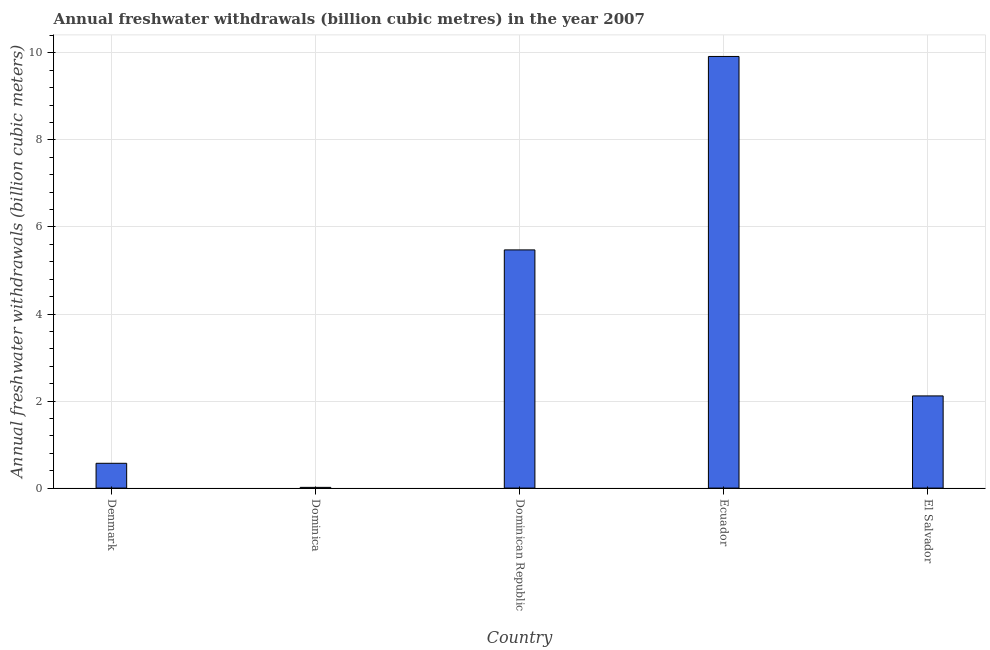Does the graph contain any zero values?
Provide a short and direct response. No. Does the graph contain grids?
Your answer should be compact. Yes. What is the title of the graph?
Give a very brief answer. Annual freshwater withdrawals (billion cubic metres) in the year 2007. What is the label or title of the Y-axis?
Offer a terse response. Annual freshwater withdrawals (billion cubic meters). What is the annual freshwater withdrawals in Denmark?
Your answer should be very brief. 0.57. Across all countries, what is the maximum annual freshwater withdrawals?
Your response must be concise. 9.92. Across all countries, what is the minimum annual freshwater withdrawals?
Make the answer very short. 0.02. In which country was the annual freshwater withdrawals maximum?
Offer a very short reply. Ecuador. In which country was the annual freshwater withdrawals minimum?
Provide a succinct answer. Dominica. What is the sum of the annual freshwater withdrawals?
Make the answer very short. 18.1. What is the difference between the annual freshwater withdrawals in Dominican Republic and Ecuador?
Make the answer very short. -4.45. What is the average annual freshwater withdrawals per country?
Keep it short and to the point. 3.62. What is the median annual freshwater withdrawals?
Offer a terse response. 2.12. What is the ratio of the annual freshwater withdrawals in Dominica to that in El Salvador?
Your answer should be very brief. 0.01. What is the difference between the highest and the second highest annual freshwater withdrawals?
Provide a short and direct response. 4.45. Is the sum of the annual freshwater withdrawals in Dominica and El Salvador greater than the maximum annual freshwater withdrawals across all countries?
Give a very brief answer. No. What is the difference between the highest and the lowest annual freshwater withdrawals?
Keep it short and to the point. 9.9. Are all the bars in the graph horizontal?
Your answer should be very brief. No. How many countries are there in the graph?
Your answer should be very brief. 5. Are the values on the major ticks of Y-axis written in scientific E-notation?
Keep it short and to the point. No. What is the Annual freshwater withdrawals (billion cubic meters) in Denmark?
Ensure brevity in your answer.  0.57. What is the Annual freshwater withdrawals (billion cubic meters) in Dominica?
Provide a succinct answer. 0.02. What is the Annual freshwater withdrawals (billion cubic meters) of Dominican Republic?
Provide a short and direct response. 5.47. What is the Annual freshwater withdrawals (billion cubic meters) of Ecuador?
Offer a very short reply. 9.92. What is the Annual freshwater withdrawals (billion cubic meters) of El Salvador?
Your response must be concise. 2.12. What is the difference between the Annual freshwater withdrawals (billion cubic meters) in Denmark and Dominica?
Your response must be concise. 0.55. What is the difference between the Annual freshwater withdrawals (billion cubic meters) in Denmark and Dominican Republic?
Offer a terse response. -4.9. What is the difference between the Annual freshwater withdrawals (billion cubic meters) in Denmark and Ecuador?
Your response must be concise. -9.35. What is the difference between the Annual freshwater withdrawals (billion cubic meters) in Denmark and El Salvador?
Provide a succinct answer. -1.55. What is the difference between the Annual freshwater withdrawals (billion cubic meters) in Dominica and Dominican Republic?
Your response must be concise. -5.46. What is the difference between the Annual freshwater withdrawals (billion cubic meters) in Dominica and Ecuador?
Your answer should be compact. -9.9. What is the difference between the Annual freshwater withdrawals (billion cubic meters) in Dominica and El Salvador?
Ensure brevity in your answer.  -2.1. What is the difference between the Annual freshwater withdrawals (billion cubic meters) in Dominican Republic and Ecuador?
Your answer should be compact. -4.45. What is the difference between the Annual freshwater withdrawals (billion cubic meters) in Dominican Republic and El Salvador?
Make the answer very short. 3.35. What is the ratio of the Annual freshwater withdrawals (billion cubic meters) in Denmark to that in Dominica?
Provide a short and direct response. 34.34. What is the ratio of the Annual freshwater withdrawals (billion cubic meters) in Denmark to that in Dominican Republic?
Your answer should be very brief. 0.1. What is the ratio of the Annual freshwater withdrawals (billion cubic meters) in Denmark to that in Ecuador?
Offer a very short reply. 0.06. What is the ratio of the Annual freshwater withdrawals (billion cubic meters) in Denmark to that in El Salvador?
Make the answer very short. 0.27. What is the ratio of the Annual freshwater withdrawals (billion cubic meters) in Dominica to that in Dominican Republic?
Give a very brief answer. 0. What is the ratio of the Annual freshwater withdrawals (billion cubic meters) in Dominica to that in Ecuador?
Your answer should be compact. 0. What is the ratio of the Annual freshwater withdrawals (billion cubic meters) in Dominica to that in El Salvador?
Keep it short and to the point. 0.01. What is the ratio of the Annual freshwater withdrawals (billion cubic meters) in Dominican Republic to that in Ecuador?
Provide a succinct answer. 0.55. What is the ratio of the Annual freshwater withdrawals (billion cubic meters) in Dominican Republic to that in El Salvador?
Provide a succinct answer. 2.58. What is the ratio of the Annual freshwater withdrawals (billion cubic meters) in Ecuador to that in El Salvador?
Ensure brevity in your answer.  4.68. 